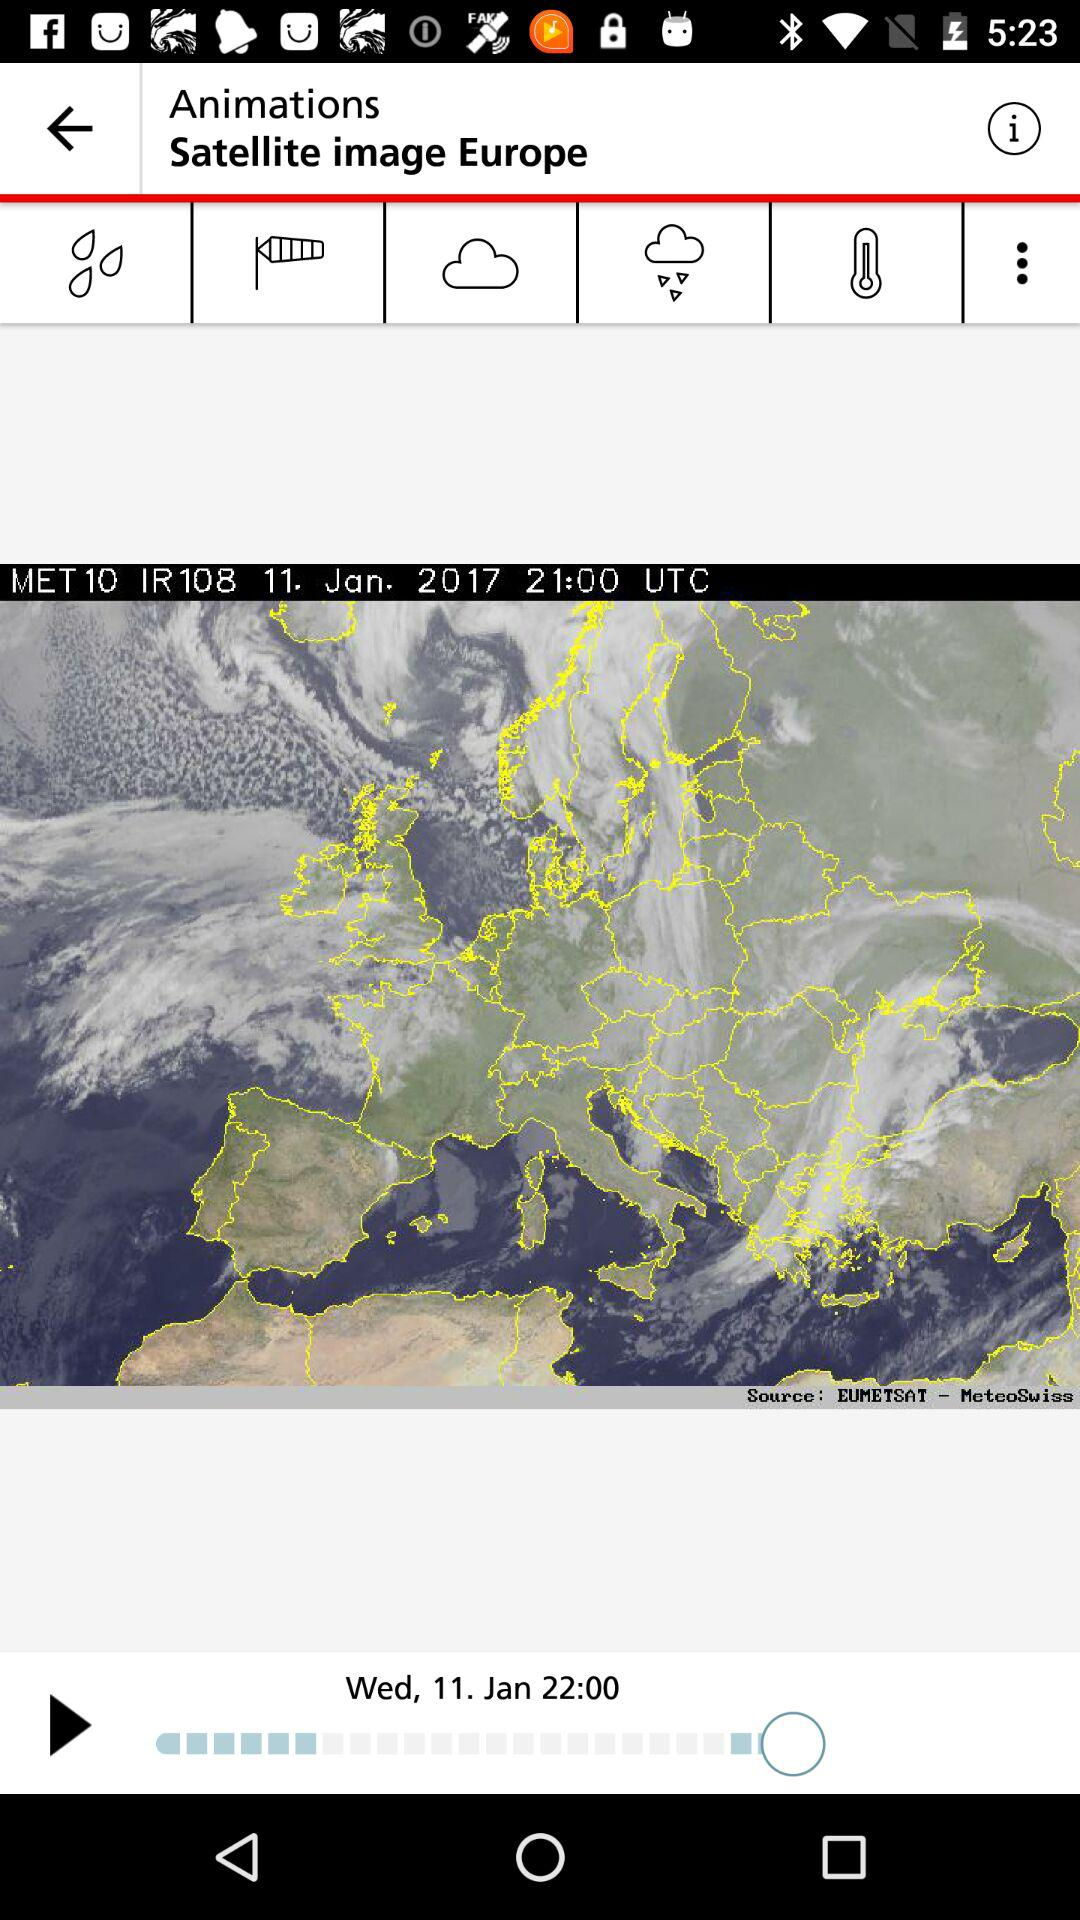What date is reflected? The reflected date is January 11, 2017. 